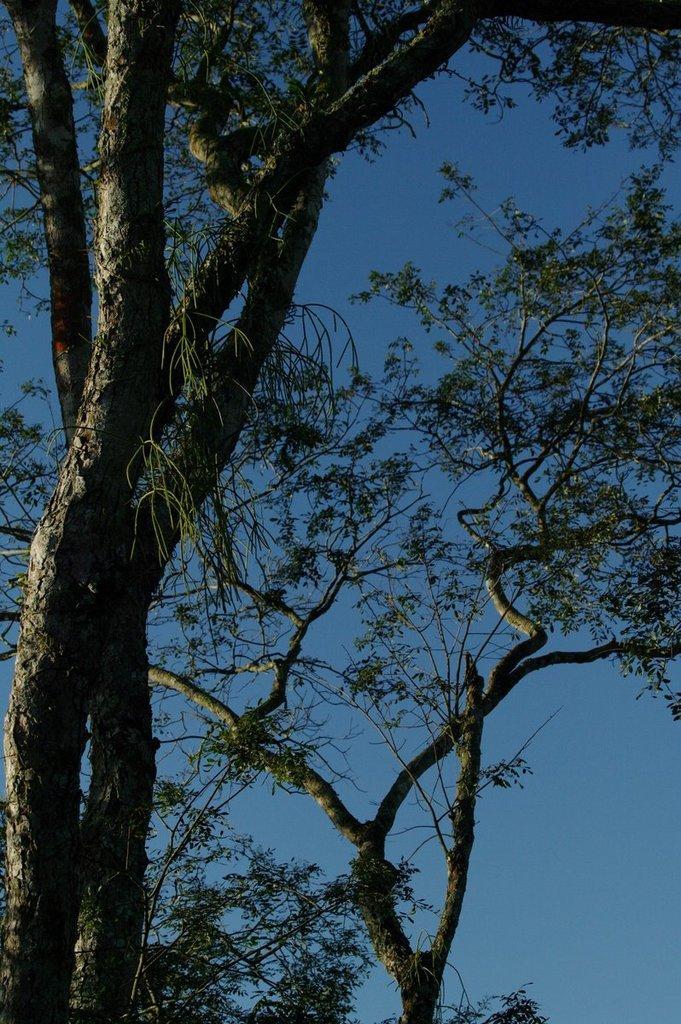Could you give a brief overview of what you see in this image? In this image I can see trees and the sky. This image is taken may be in the evening. 